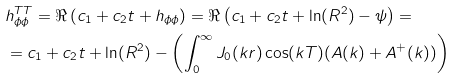Convert formula to latex. <formula><loc_0><loc_0><loc_500><loc_500>& h ^ { T T } _ { \phi \phi } = \Re \left ( c _ { 1 } + c _ { 2 } t + h _ { \phi \phi } \right ) = \Re \left ( c _ { 1 } + c _ { 2 } t + \ln ( R ^ { 2 } ) - \psi \right ) = \\ & = c _ { 1 } + c _ { 2 } t + \ln ( R ^ { 2 } ) - \left ( \int _ { 0 } ^ { \infty } J _ { 0 } ( k r ) \cos ( k T ) ( A ( k ) + A ^ { + } ( k ) ) \right )</formula> 